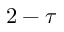Convert formula to latex. <formula><loc_0><loc_0><loc_500><loc_500>2 - \tau</formula> 